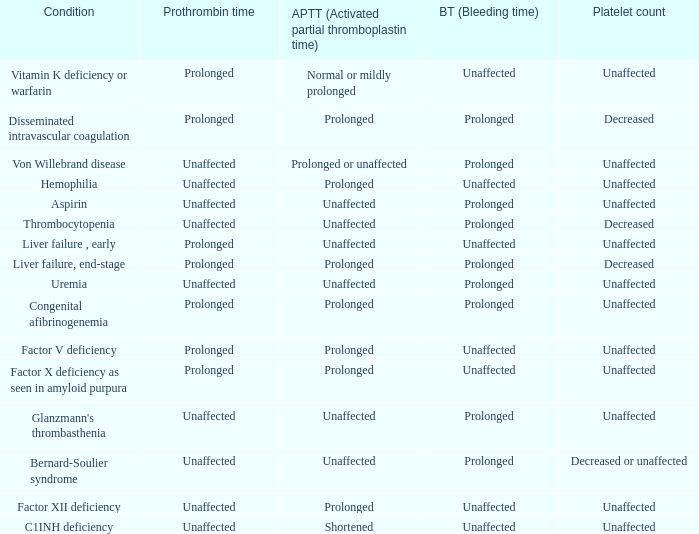Help me parse the entirety of this table. {'header': ['Condition', 'Prothrombin time', 'APTT (Activated partial thromboplastin time)', 'BT (Bleeding time)', 'Platelet count'], 'rows': [['Vitamin K deficiency or warfarin', 'Prolonged', 'Normal or mildly prolonged', 'Unaffected', 'Unaffected'], ['Disseminated intravascular coagulation', 'Prolonged', 'Prolonged', 'Prolonged', 'Decreased'], ['Von Willebrand disease', 'Unaffected', 'Prolonged or unaffected', 'Prolonged', 'Unaffected'], ['Hemophilia', 'Unaffected', 'Prolonged', 'Unaffected', 'Unaffected'], ['Aspirin', 'Unaffected', 'Unaffected', 'Prolonged', 'Unaffected'], ['Thrombocytopenia', 'Unaffected', 'Unaffected', 'Prolonged', 'Decreased'], ['Liver failure , early', 'Prolonged', 'Unaffected', 'Unaffected', 'Unaffected'], ['Liver failure, end-stage', 'Prolonged', 'Prolonged', 'Prolonged', 'Decreased'], ['Uremia', 'Unaffected', 'Unaffected', 'Prolonged', 'Unaffected'], ['Congenital afibrinogenemia', 'Prolonged', 'Prolonged', 'Prolonged', 'Unaffected'], ['Factor V deficiency', 'Prolonged', 'Prolonged', 'Unaffected', 'Unaffected'], ['Factor X deficiency as seen in amyloid purpura', 'Prolonged', 'Prolonged', 'Unaffected', 'Unaffected'], ["Glanzmann's thrombasthenia", 'Unaffected', 'Unaffected', 'Prolonged', 'Unaffected'], ['Bernard-Soulier syndrome', 'Unaffected', 'Unaffected', 'Prolonged', 'Decreased or unaffected'], ['Factor XII deficiency', 'Unaffected', 'Prolonged', 'Unaffected', 'Unaffected'], ['C1INH deficiency', 'Unaffected', 'Shortened', 'Unaffected', 'Unaffected']]} Which Condition has a Bleeding time of unaffected, and a Partial thromboplastin time of prolonged, and a Prothrombin time of unaffected? Hemophilia, Factor XII deficiency. 